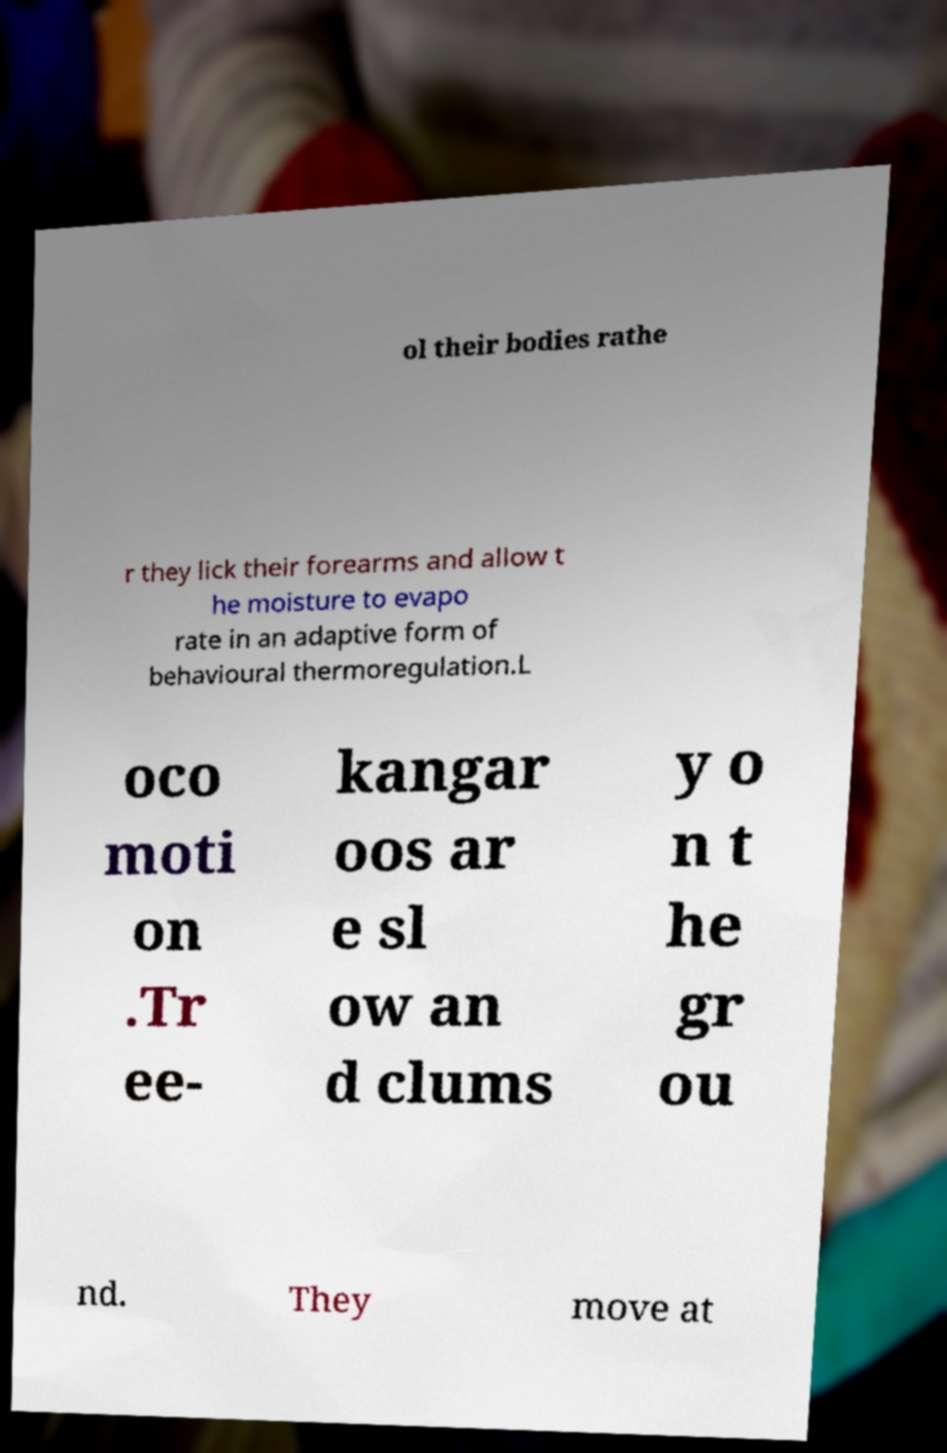What messages or text are displayed in this image? I need them in a readable, typed format. ol their bodies rathe r they lick their forearms and allow t he moisture to evapo rate in an adaptive form of behavioural thermoregulation.L oco moti on .Tr ee- kangar oos ar e sl ow an d clums y o n t he gr ou nd. They move at 